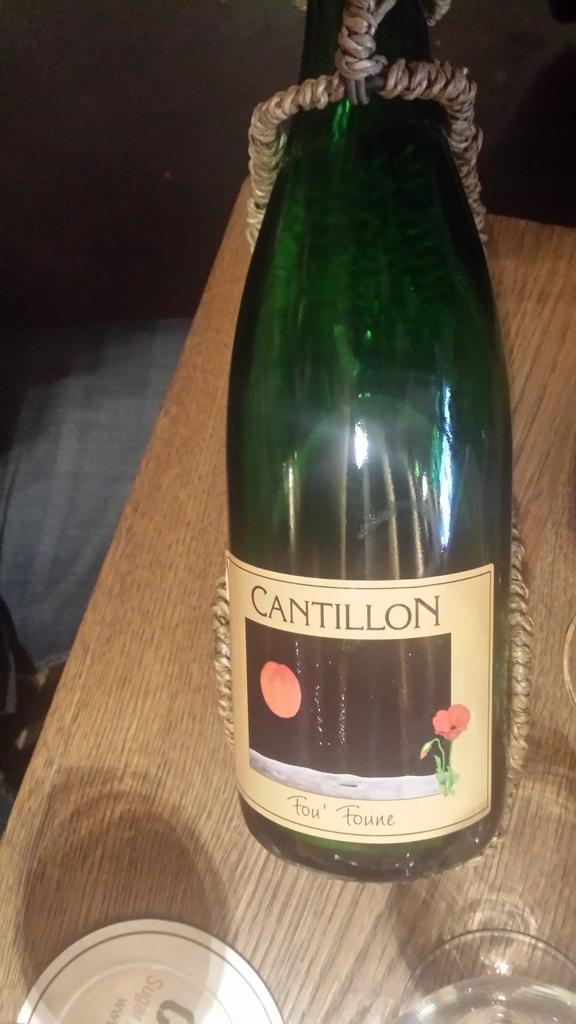<image>
Create a compact narrative representing the image presented. Green wine bottle that says "Cantillon" on the top. 